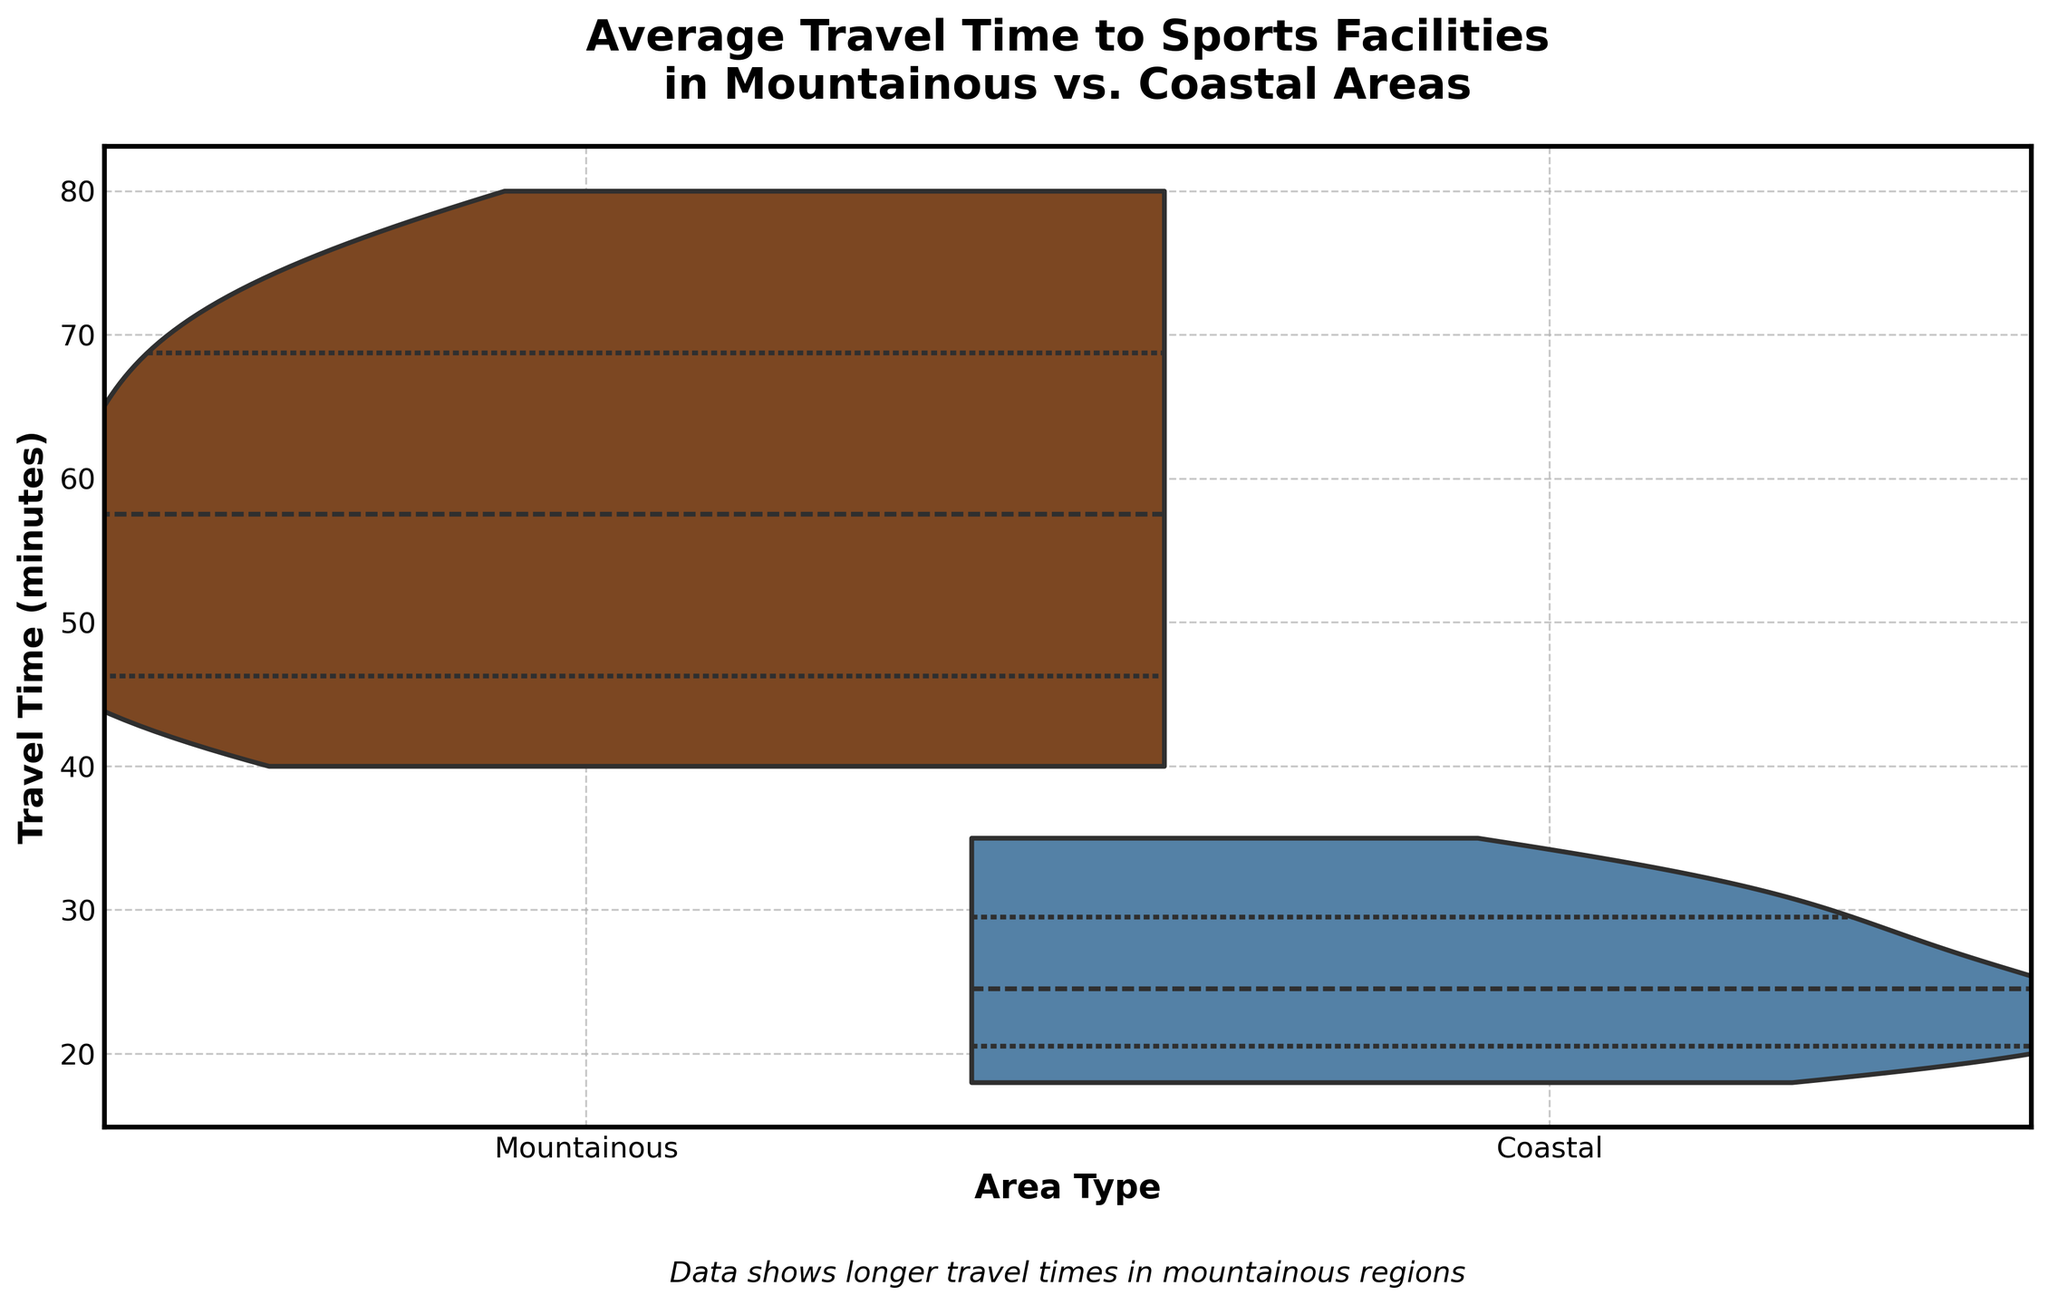What is the title of the plot? The title is usually prominently displayed at the top of the plot and it provides a succinct summary of the data visualization. In this plot, the title is: "Average Travel Time to Sports Facilities in Mountainous vs. Coastal Areas."
Answer: Average Travel Time to Sports Facilities in Mountainous vs. Coastal Areas What are the two area types compared in the plot? The x-axis represents the categories being compared, which are labeled "Mountainous" and "Coastal".
Answer: Mountainous and Coastal Which area type shows generally longer travel times to sports facilities? By observing the position of the violins along the y-axis, the Mountainous areas have a higher concentration of data points at higher travel times compared to Coastal areas.
Answer: Mountainous What is the range of travel times observed for Coastal areas? The Coastal area's violin extends from approximately 18 minutes to 35 minutes on the y-axis.
Answer: 18 to 35 minutes What is the median travel time for Mountainous areas based on the inner quartile shown in the violin plot? The inner quartile or median is generally marked within the violin plot. For Mountainous areas, the median travel time appears around 60 minutes.
Answer: ~60 minutes How much longer is the average travel time in Mountainous areas compared to Coastal areas? The average travel time in each area can be approximated by looking at the center of the violins. For Mountainous areas, it is around 60 minutes, while for Coastal areas, it is around 25 minutes. The difference is 60 - 25 = 35 minutes.
Answer: ~35 minutes What type of trend can be observed with respect to travel times in Coastal areas? The distribution of travel times in Coastal areas shows a narrower and lower range, indicating more consistency and shorter travel times.
Answer: Consistent and shorter travel times Compare the spread of travel times in Mountainous vs. Coastal areas. The spread of travel times, indicated by the width and length of the violins, is broader in Mountainous areas (approximately 40 to 80 minutes) compared to Coastal areas (approximately 18 to 35 minutes).
Answer: Broader spread in Mountainous areas What does the italicized text below the plot indicate? The text provides a summary of a key insight from the plot: "Data shows longer travel times in mountainous regions."
Answer: Data shows longer travel times in mountainous regions What is the purpose of the split in the violin plot? The split in the violin plot allows for the comparison of two categories within the same visual space, making it easier to contrast their distributions directly.
Answer: To compare distributions 